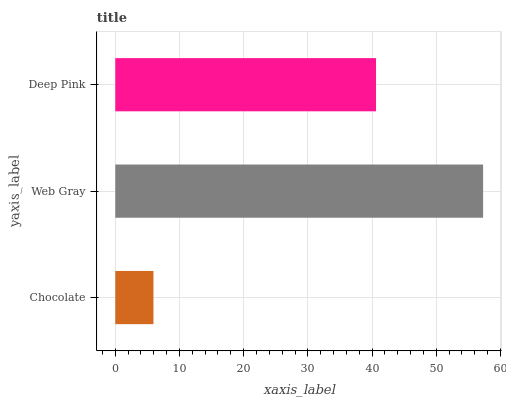Is Chocolate the minimum?
Answer yes or no. Yes. Is Web Gray the maximum?
Answer yes or no. Yes. Is Deep Pink the minimum?
Answer yes or no. No. Is Deep Pink the maximum?
Answer yes or no. No. Is Web Gray greater than Deep Pink?
Answer yes or no. Yes. Is Deep Pink less than Web Gray?
Answer yes or no. Yes. Is Deep Pink greater than Web Gray?
Answer yes or no. No. Is Web Gray less than Deep Pink?
Answer yes or no. No. Is Deep Pink the high median?
Answer yes or no. Yes. Is Deep Pink the low median?
Answer yes or no. Yes. Is Web Gray the high median?
Answer yes or no. No. Is Chocolate the low median?
Answer yes or no. No. 